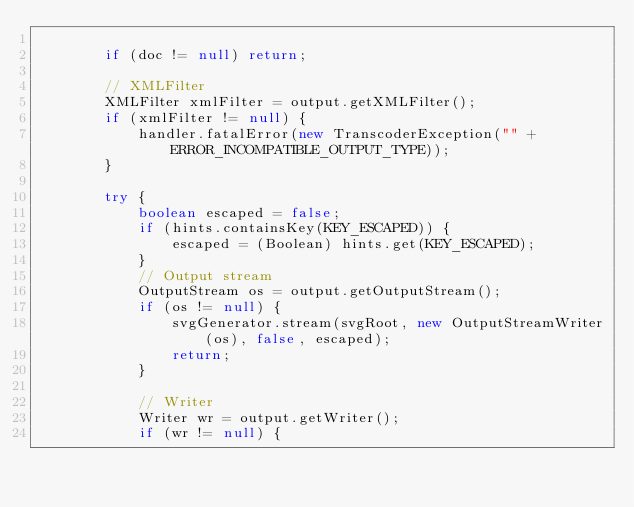<code> <loc_0><loc_0><loc_500><loc_500><_Java_>
        if (doc != null) return;

        // XMLFilter
        XMLFilter xmlFilter = output.getXMLFilter();
        if (xmlFilter != null) {
            handler.fatalError(new TranscoderException("" + ERROR_INCOMPATIBLE_OUTPUT_TYPE));
        }

        try {
            boolean escaped = false;
            if (hints.containsKey(KEY_ESCAPED)) {
                escaped = (Boolean) hints.get(KEY_ESCAPED);
            }
            // Output stream
            OutputStream os = output.getOutputStream();
            if (os != null) {
                svgGenerator.stream(svgRoot, new OutputStreamWriter(os), false, escaped);
                return;
            }

            // Writer
            Writer wr = output.getWriter();
            if (wr != null) {</code> 